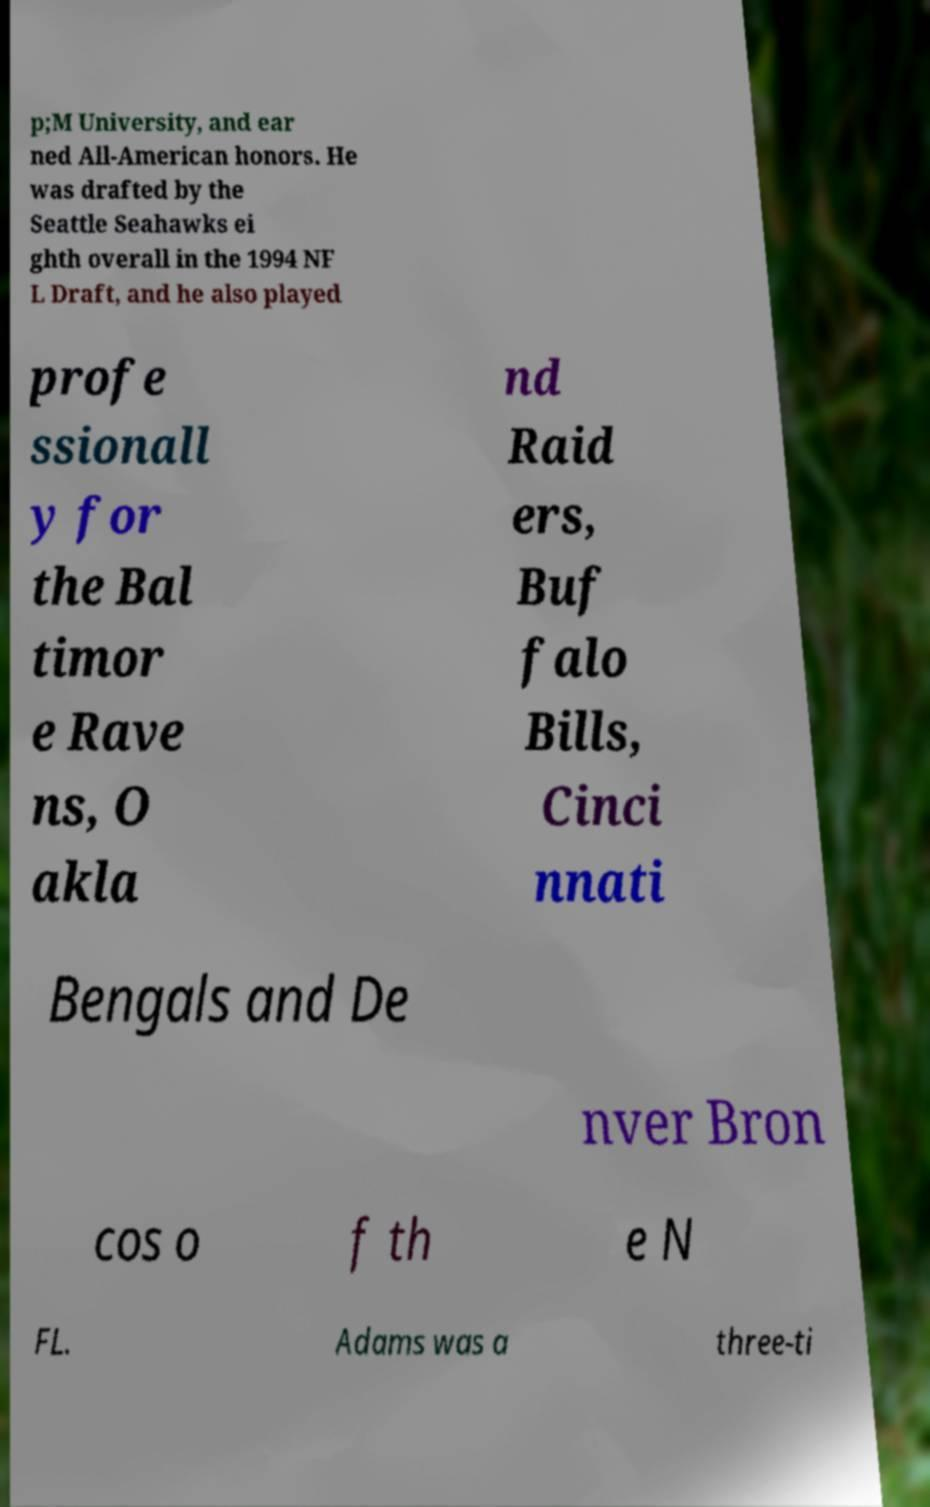I need the written content from this picture converted into text. Can you do that? p;M University, and ear ned All-American honors. He was drafted by the Seattle Seahawks ei ghth overall in the 1994 NF L Draft, and he also played profe ssionall y for the Bal timor e Rave ns, O akla nd Raid ers, Buf falo Bills, Cinci nnati Bengals and De nver Bron cos o f th e N FL. Adams was a three-ti 